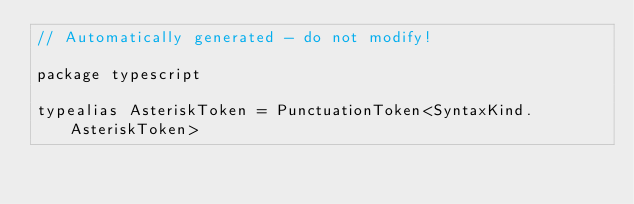<code> <loc_0><loc_0><loc_500><loc_500><_Kotlin_>// Automatically generated - do not modify!

package typescript

typealias AsteriskToken = PunctuationToken<SyntaxKind.AsteriskToken>
</code> 